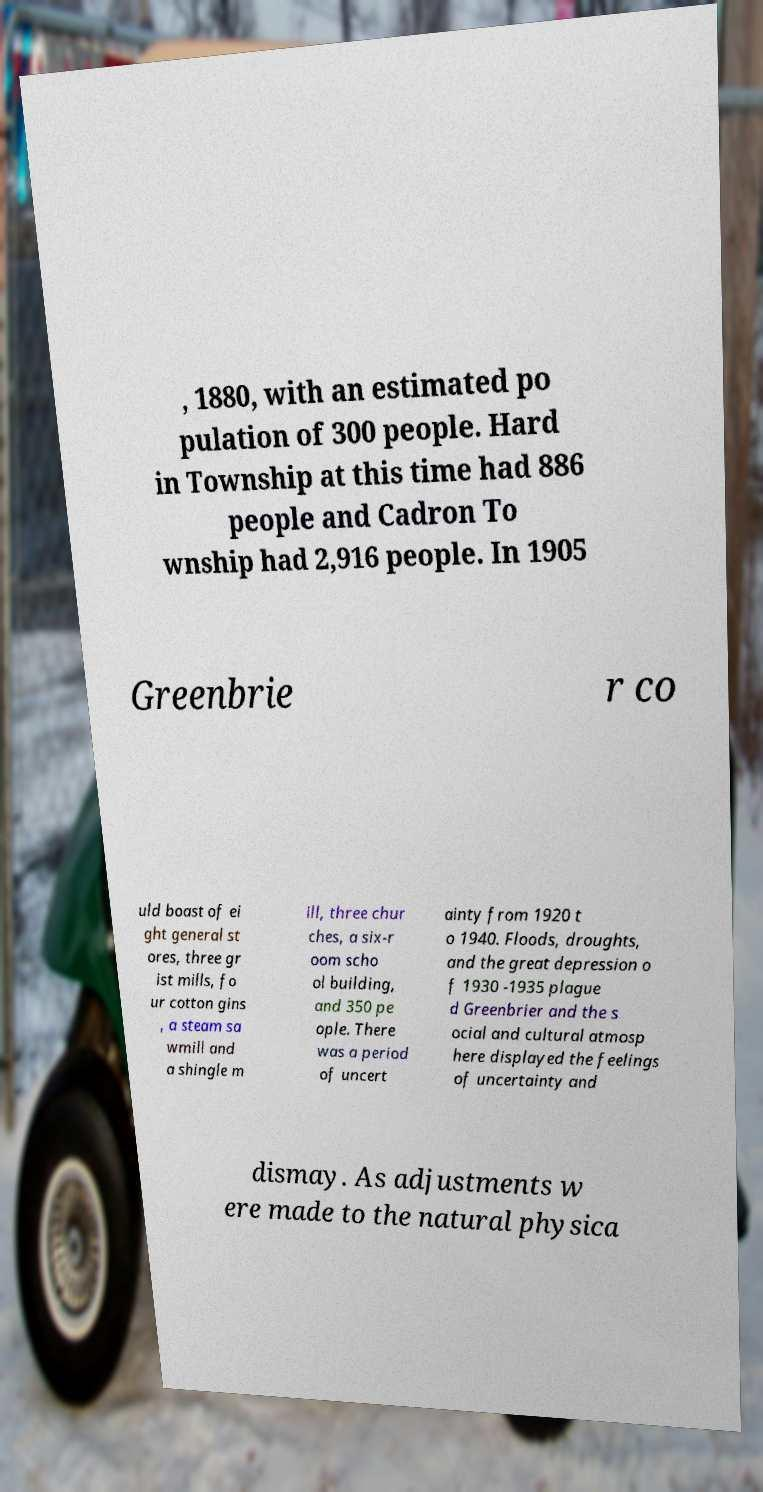There's text embedded in this image that I need extracted. Can you transcribe it verbatim? , 1880, with an estimated po pulation of 300 people. Hard in Township at this time had 886 people and Cadron To wnship had 2,916 people. In 1905 Greenbrie r co uld boast of ei ght general st ores, three gr ist mills, fo ur cotton gins , a steam sa wmill and a shingle m ill, three chur ches, a six-r oom scho ol building, and 350 pe ople. There was a period of uncert ainty from 1920 t o 1940. Floods, droughts, and the great depression o f 1930 -1935 plague d Greenbrier and the s ocial and cultural atmosp here displayed the feelings of uncertainty and dismay. As adjustments w ere made to the natural physica 